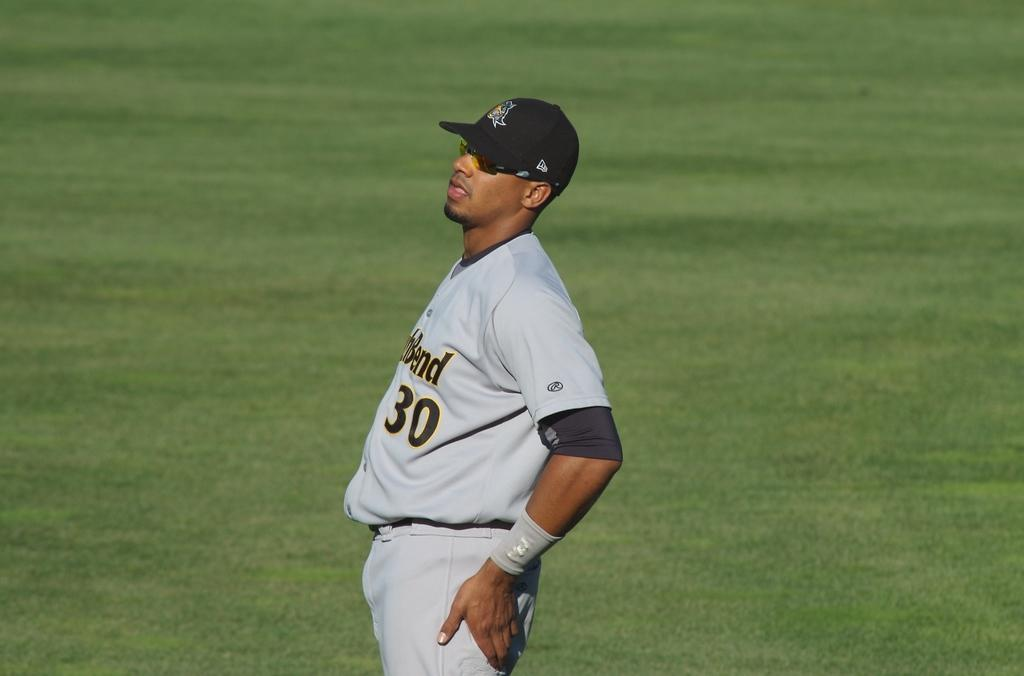<image>
Describe the image concisely. A baseball player with the partial word Bend on his jersey. 